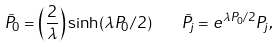Convert formula to latex. <formula><loc_0><loc_0><loc_500><loc_500>\tilde { P } _ { 0 } = \left ( \frac { 2 } { \lambda } \right ) \sinh ( \lambda { P } _ { 0 } / 2 ) \quad \tilde { P } _ { j } = e ^ { \lambda { P } _ { 0 } / 2 } { P } _ { j } ,</formula> 